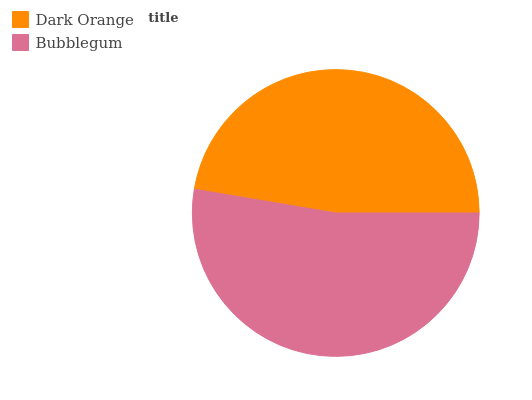Is Dark Orange the minimum?
Answer yes or no. Yes. Is Bubblegum the maximum?
Answer yes or no. Yes. Is Bubblegum the minimum?
Answer yes or no. No. Is Bubblegum greater than Dark Orange?
Answer yes or no. Yes. Is Dark Orange less than Bubblegum?
Answer yes or no. Yes. Is Dark Orange greater than Bubblegum?
Answer yes or no. No. Is Bubblegum less than Dark Orange?
Answer yes or no. No. Is Bubblegum the high median?
Answer yes or no. Yes. Is Dark Orange the low median?
Answer yes or no. Yes. Is Dark Orange the high median?
Answer yes or no. No. Is Bubblegum the low median?
Answer yes or no. No. 